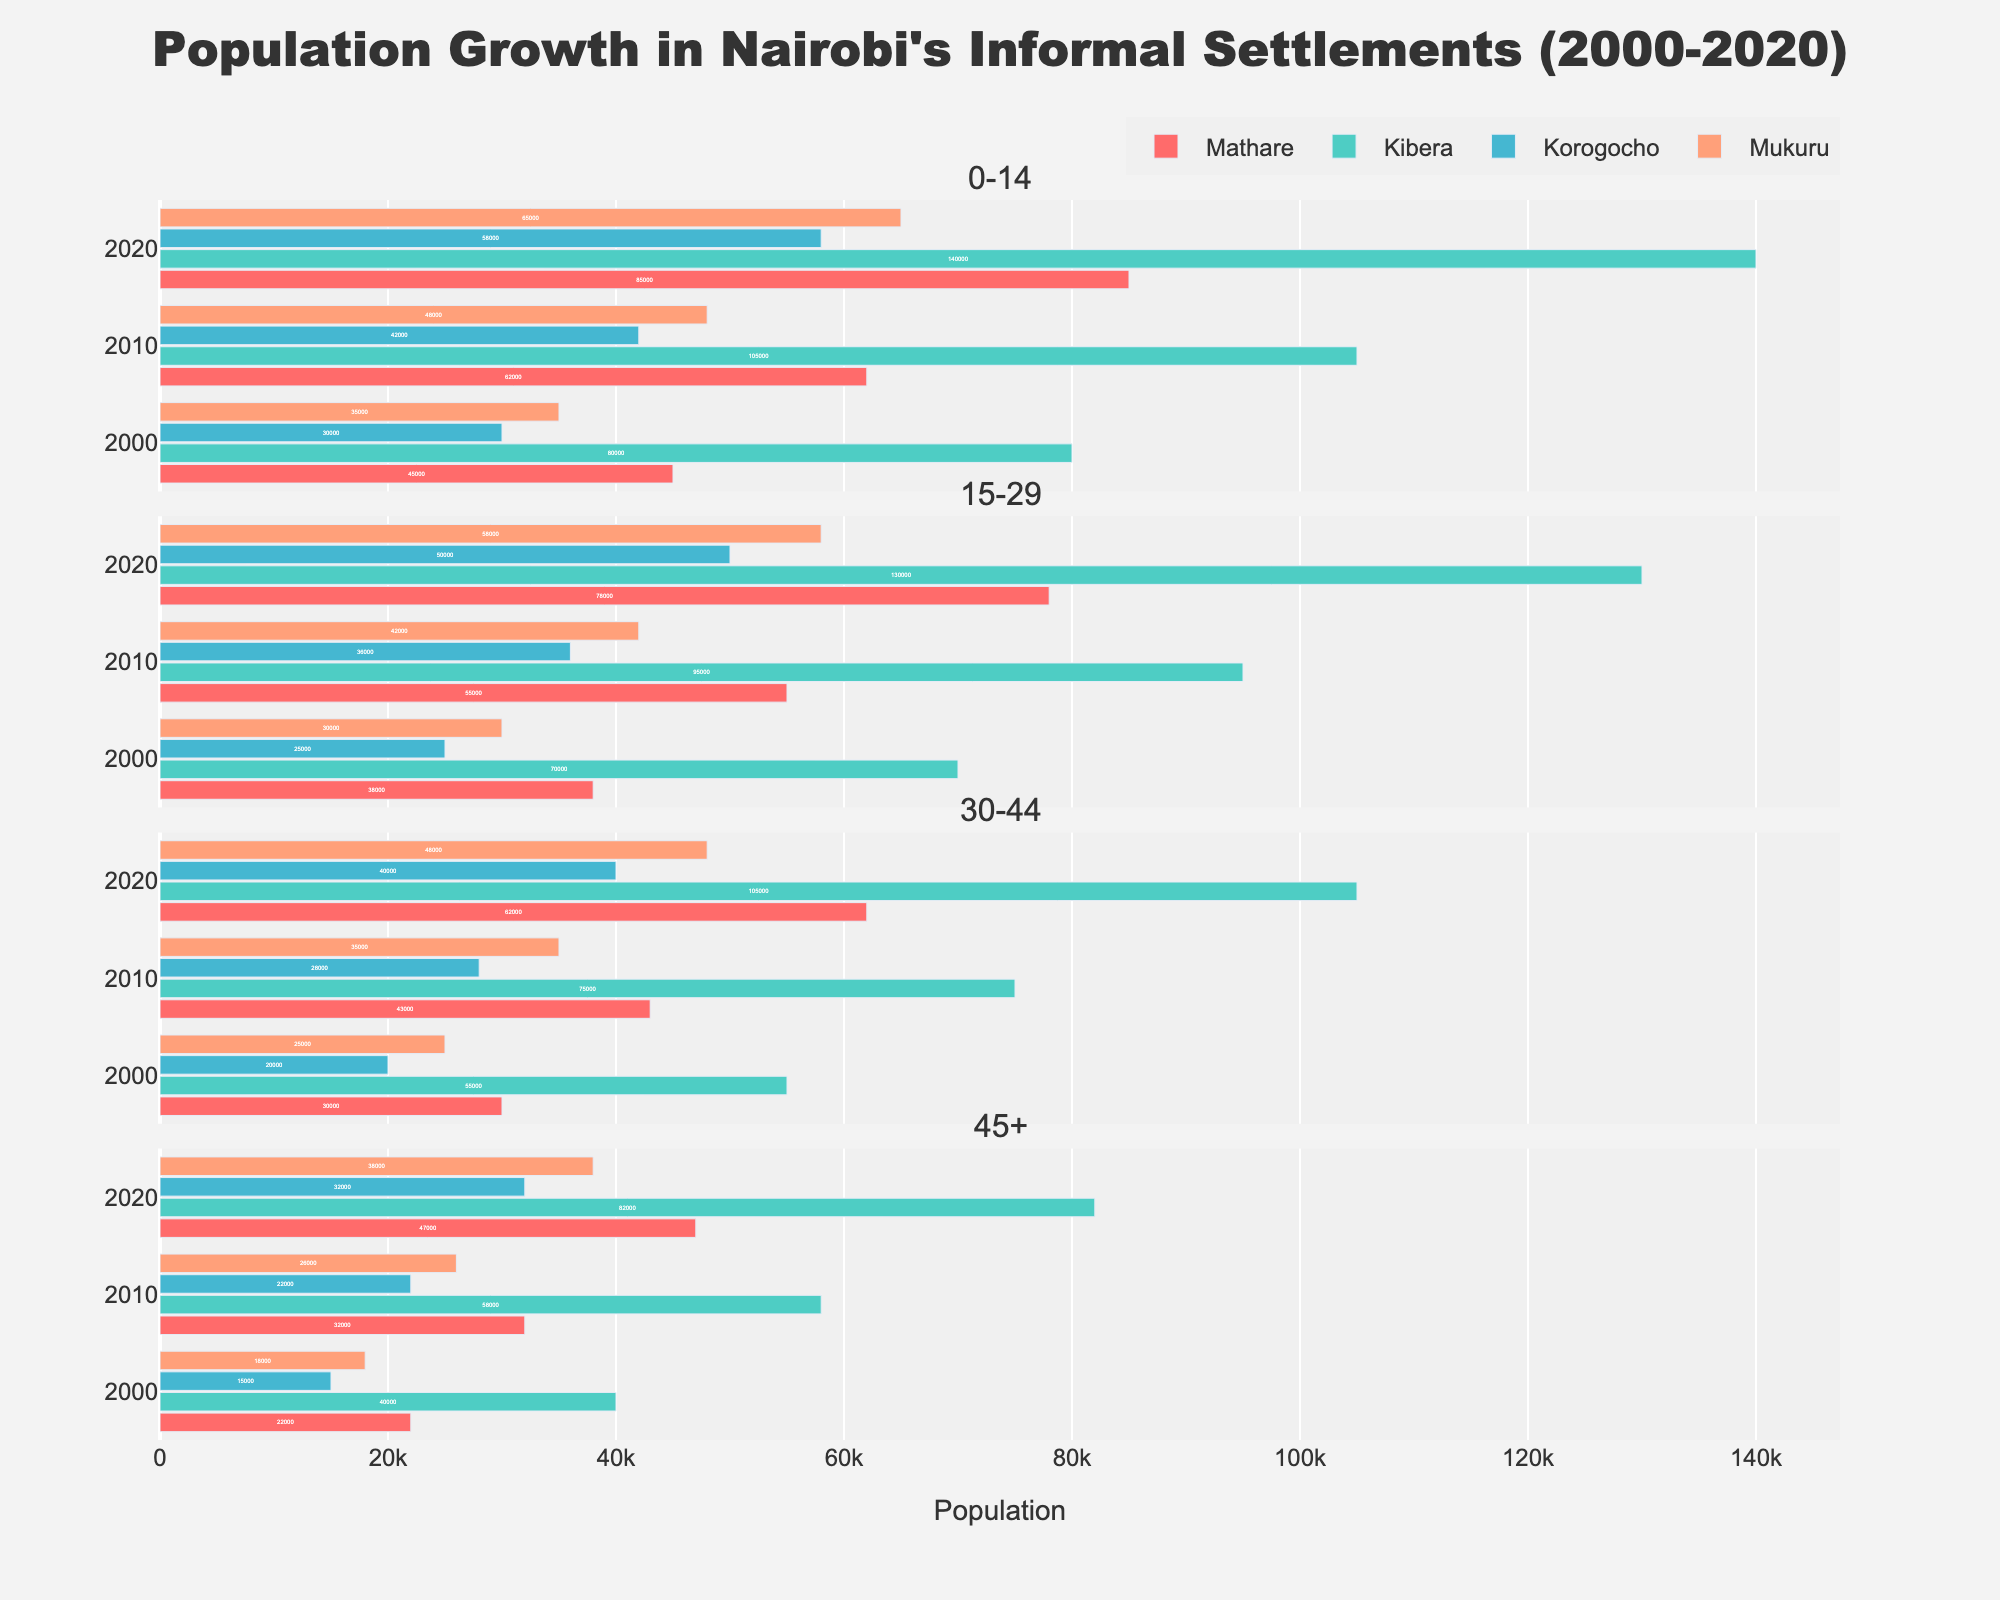What is the title of the figure? The figure title is usually placed at the top, centered and often larger in font size. Looking at the top, it says "Population Growth in Nairobi's Informal Settlements (2000-2020)."
Answer: Population Growth in Nairobi's Informal Settlements (2000-2020) Which informal settlement had the highest population in the age group 0-14 in the year 2020? Find the subplot for age group 0-14, then locate the bar corresponding to 2020. Compare the bar lengths for Mathare, Kibera, Korogocho, and Mukuru. The bar for Kibera is the longest.
Answer: Kibera What is the population difference between Mathare and Kibera for the age group 15-29 in the year 2020? Identify the subgroup for age 15-29 and the bar for the year 2020. Read the values for Mathare and Kibera and calculate the difference: 130,000 - 78,000 = 52,000.
Answer: 52,000 In which year did Mathare see the highest population in the age group 45+? Identify the subplot for the age group 45+ and compare the three bars for Mathare. The longest bar corresponds to the year 2020.
Answer: 2020 Which age group in Korogocho saw the largest absolute population growth between 2000 and 2020? For Korogocho, compare the population values for each age group in 2000 and 2020. Calculate the absolute growth: 0-14 (58,000-30,000=28,000), 15-29 (50,000-25,000=25,000), 30-44 (40,000-20,000=20,000), 45+ (32,000-15,000=17,000). The largest growth is in the 0-14 age group.
Answer: 0-14 Between 2000 and 2010, which settlement saw the highest increase in population for the age group 30-44? Look at the subplot for 30-44, then subtract the 2000 values from the 2010 values for each settlement: Mathare (43,000-30,000=13,000), Kibera (75,000-55,000=20,000), Korogocho (28,000-20,000=8,000), Mukuru (35,000-25,000=10,000). Kibera has the highest increase.
Answer: Kibera How does the population trend of Mukuru in the age group 0-14 compare to Kibera from 2000 to 2020? For the age group 0-14, observe the trend lines: in Mukuru the population goes from 35,000 to 65,000, while in Kibera it goes from 80,000 to 140,000. Both settlements show increasing trends, but the increase is sharper in Kibera.
Answer: Kibera increased more sharply Which age group in Mathare had the smallest population growth from 2000 to 2020? Calculate the differences for each age group: 0-14 (85,000-45,000=40,000), 15-29 (78,000-38,000=40,000), 30-44 (62,000-30,000=32,000), 45+ (47,000-22,000=25,000). The smallest growth is in the 45+ age group.
Answer: 45+ What was the population of Korogocho in the age group 30-44 in 2010? Locate the subplot for the age group 30-44 and read the value for Korogocho in 2010.
Answer: 28,000 Which age group showed the most significant increase in population across all settlements from 2000 to 2020? Observe all subplots and calculate the overall growth for each age group: 0-14 [(85000+140000+58000+65000)-(45000+80000+30000+35000)], 15-29 [(78000+130000+50000+58000)-(38000+70000+25000+30000)], 30-44 [(62000+105000+40000+48000)-(30000+55000+20000+25000)], 45+ [(47000+82000+32000+38000)-(22000+40000+15000+18000)]. The age group 0-14 shows the most significant increase.
Answer: 0-14 